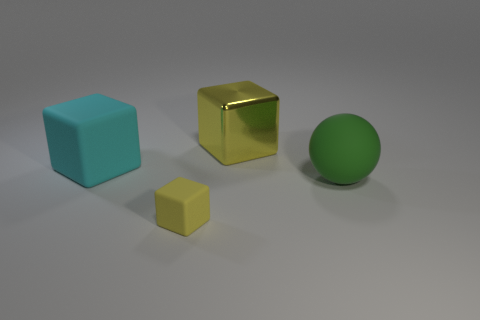Add 2 small cubes. How many objects exist? 6 Subtract all yellow cubes. How many cubes are left? 1 Subtract all large blocks. How many blocks are left? 1 Subtract 0 red balls. How many objects are left? 4 Subtract all cubes. How many objects are left? 1 Subtract 3 blocks. How many blocks are left? 0 Subtract all red balls. Subtract all brown cubes. How many balls are left? 1 Subtract all green cylinders. How many yellow blocks are left? 2 Subtract all tiny gray blocks. Subtract all big green things. How many objects are left? 3 Add 4 cyan things. How many cyan things are left? 5 